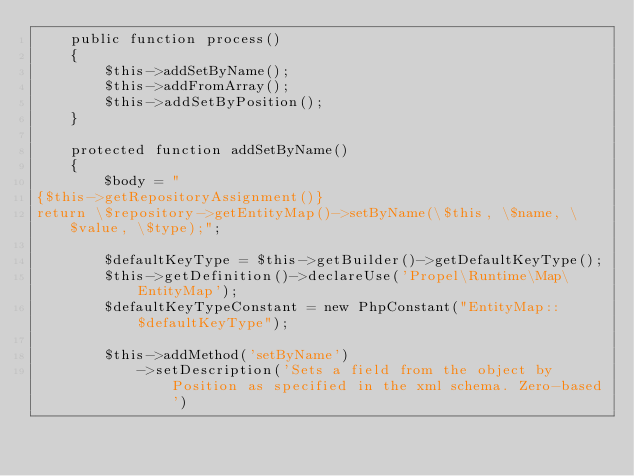<code> <loc_0><loc_0><loc_500><loc_500><_PHP_>    public function process()
    {
        $this->addSetByName();
        $this->addFromArray();
        $this->addSetByPosition();
    }

    protected function addSetByName()
    {
        $body = "
{$this->getRepositoryAssignment()}
return \$repository->getEntityMap()->setByName(\$this, \$name, \$value, \$type);";

        $defaultKeyType = $this->getBuilder()->getDefaultKeyType();
        $this->getDefinition()->declareUse('Propel\Runtime\Map\EntityMap');
        $defaultKeyTypeConstant = new PhpConstant("EntityMap::$defaultKeyType");

        $this->addMethod('setByName')
            ->setDescription('Sets a field from the object by Position as specified in the xml schema. Zero-based')</code> 